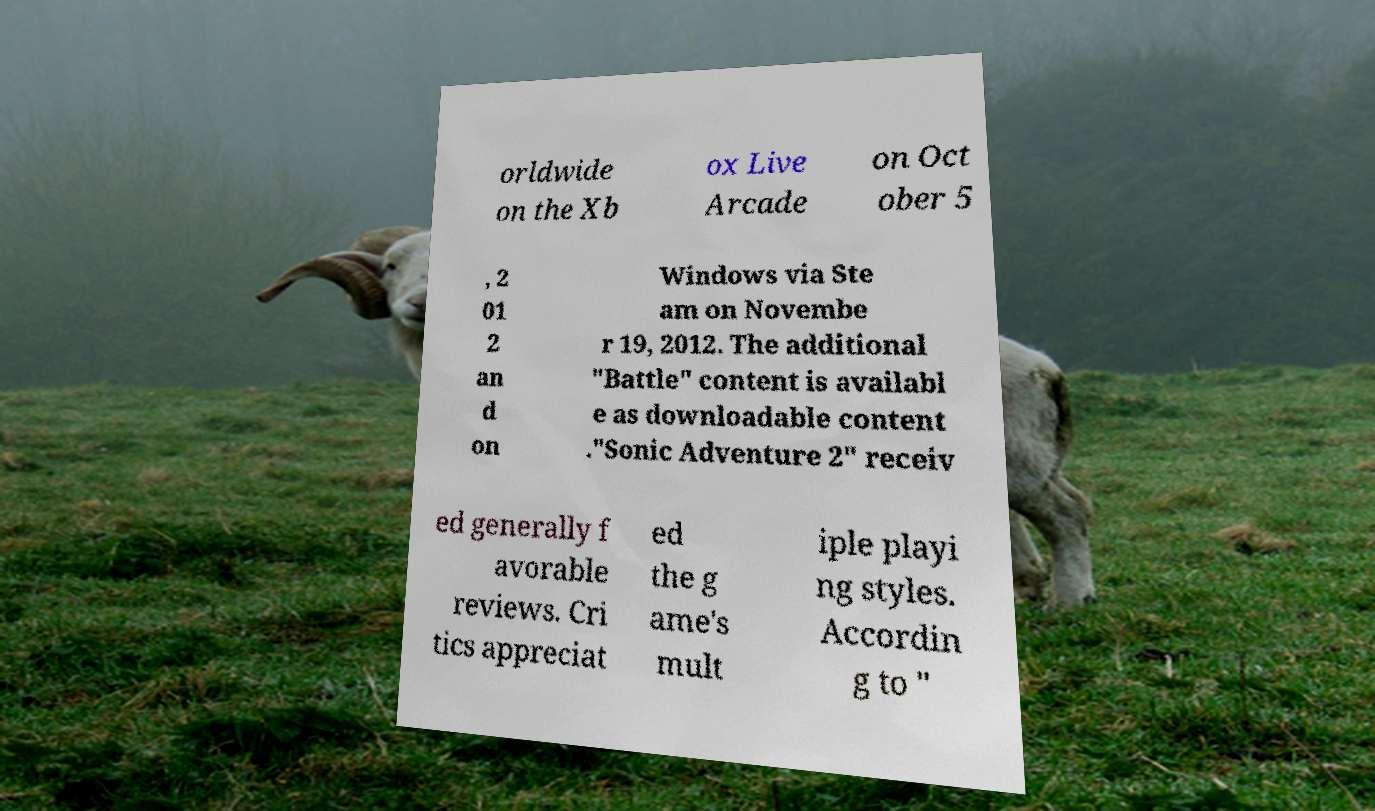Can you accurately transcribe the text from the provided image for me? orldwide on the Xb ox Live Arcade on Oct ober 5 , 2 01 2 an d on Windows via Ste am on Novembe r 19, 2012. The additional "Battle" content is availabl e as downloadable content ."Sonic Adventure 2" receiv ed generally f avorable reviews. Cri tics appreciat ed the g ame's mult iple playi ng styles. Accordin g to " 